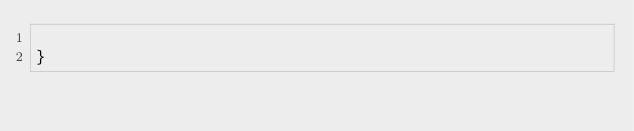<code> <loc_0><loc_0><loc_500><loc_500><_Kotlin_>
}
</code> 